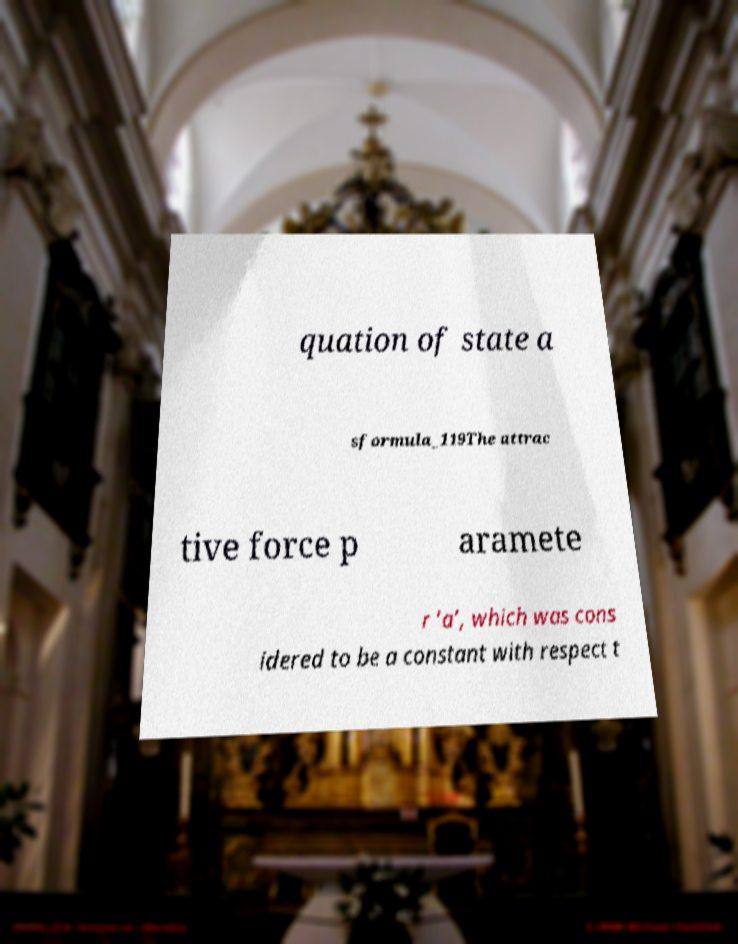Can you accurately transcribe the text from the provided image for me? quation of state a sformula_119The attrac tive force p aramete r ‘a’, which was cons idered to be a constant with respect t 